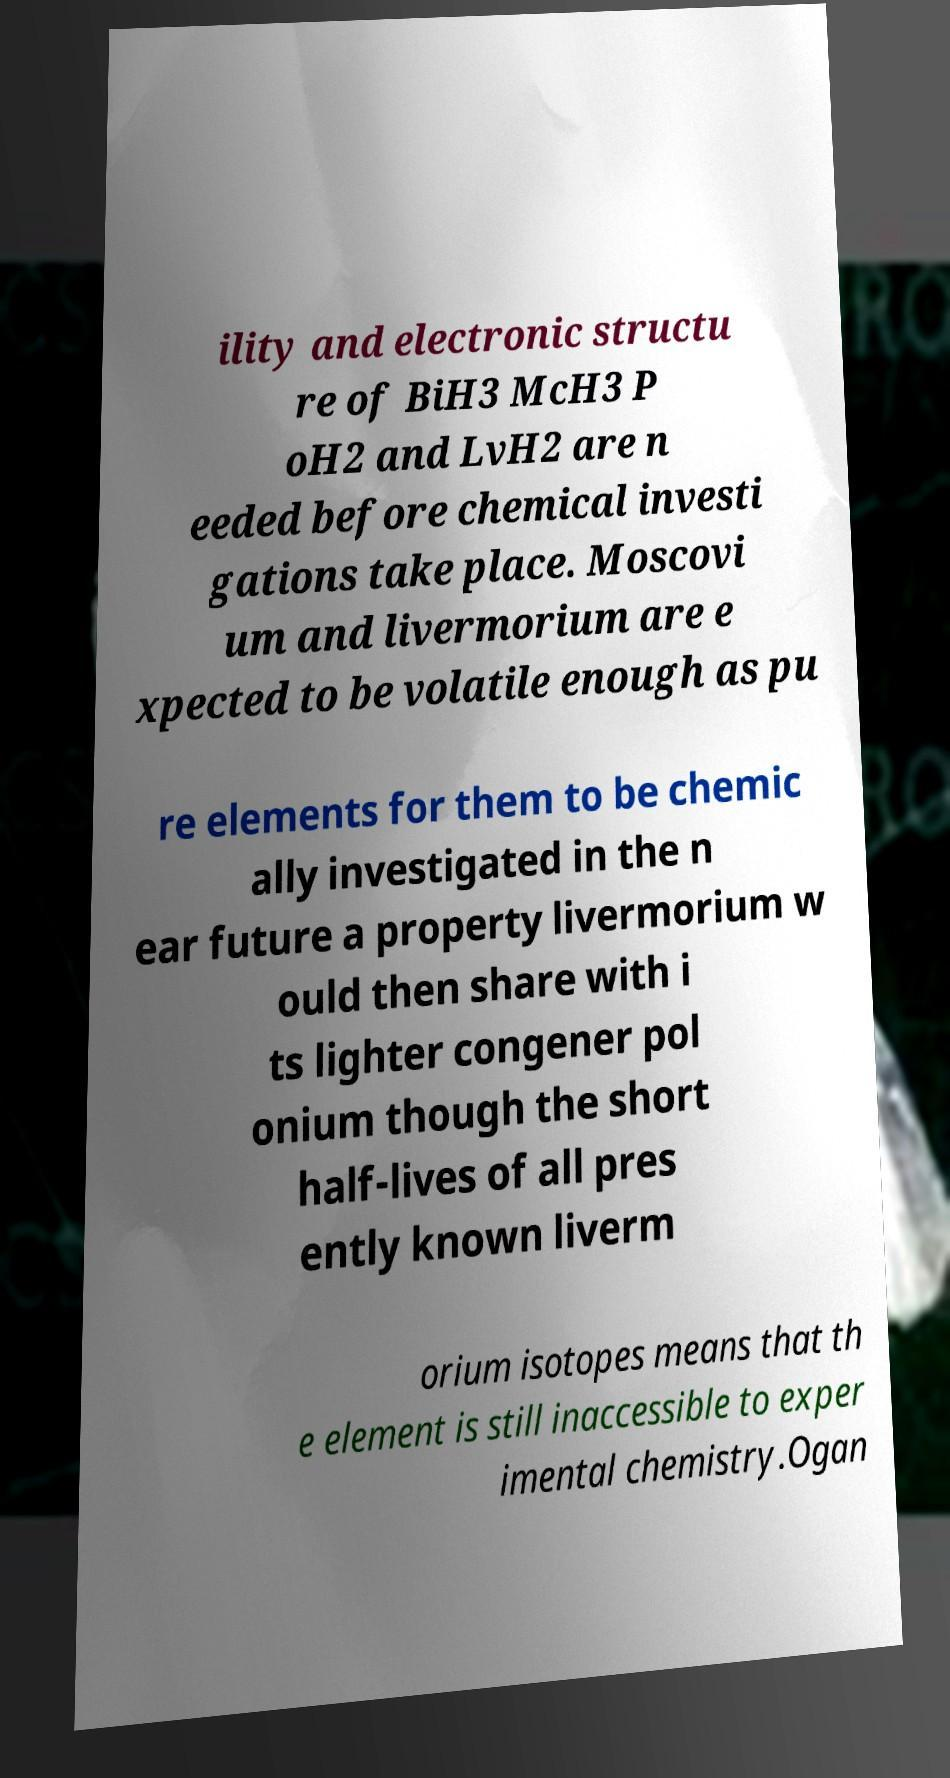There's text embedded in this image that I need extracted. Can you transcribe it verbatim? ility and electronic structu re of BiH3 McH3 P oH2 and LvH2 are n eeded before chemical investi gations take place. Moscovi um and livermorium are e xpected to be volatile enough as pu re elements for them to be chemic ally investigated in the n ear future a property livermorium w ould then share with i ts lighter congener pol onium though the short half-lives of all pres ently known liverm orium isotopes means that th e element is still inaccessible to exper imental chemistry.Ogan 